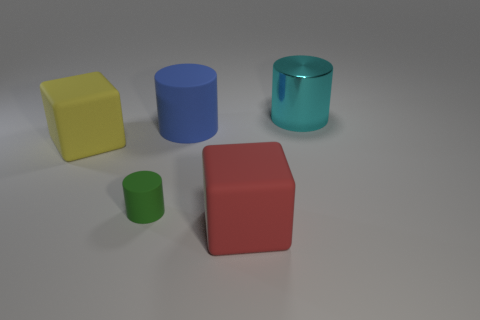Subtract all big cylinders. How many cylinders are left? 1 Add 4 tiny matte cylinders. How many objects exist? 9 Subtract 1 cylinders. How many cylinders are left? 2 Subtract all yellow cylinders. Subtract all yellow blocks. How many cylinders are left? 3 Subtract all cylinders. How many objects are left? 2 Subtract all small matte cylinders. Subtract all small brown matte blocks. How many objects are left? 4 Add 5 tiny green matte objects. How many tiny green matte objects are left? 6 Add 5 big yellow blocks. How many big yellow blocks exist? 6 Subtract 0 blue cubes. How many objects are left? 5 